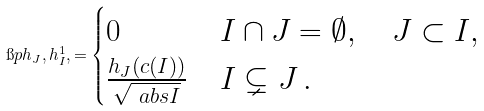<formula> <loc_0><loc_0><loc_500><loc_500>\i p h _ { J } , h ^ { 1 } _ { I } , = \begin{cases} 0 & I \cap J = \emptyset , \quad J \subset I , \\ \frac { h _ { J } ( c ( I ) ) } { \sqrt { \ a b s { I } } } & I \subsetneq J \, . \end{cases}</formula> 